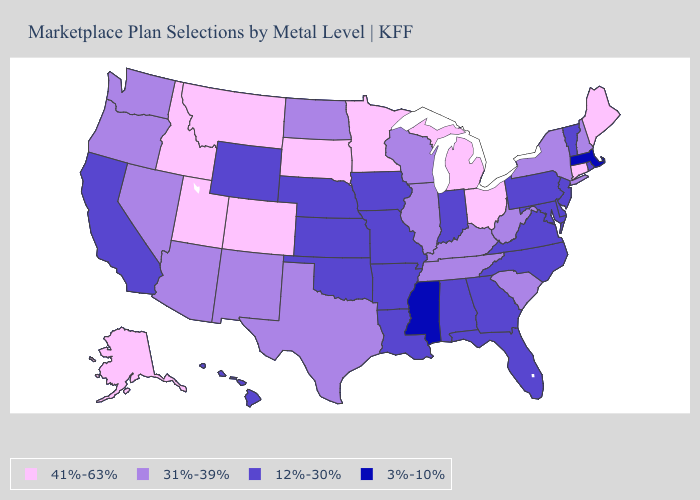Name the states that have a value in the range 41%-63%?
Be succinct. Alaska, Colorado, Connecticut, Idaho, Maine, Michigan, Minnesota, Montana, Ohio, South Dakota, Utah. What is the value of Florida?
Write a very short answer. 12%-30%. Name the states that have a value in the range 3%-10%?
Keep it brief. Massachusetts, Mississippi. What is the value of Wisconsin?
Short answer required. 31%-39%. Does the first symbol in the legend represent the smallest category?
Write a very short answer. No. Is the legend a continuous bar?
Write a very short answer. No. Which states have the lowest value in the MidWest?
Be succinct. Indiana, Iowa, Kansas, Missouri, Nebraska. Name the states that have a value in the range 3%-10%?
Short answer required. Massachusetts, Mississippi. What is the value of Oklahoma?
Keep it brief. 12%-30%. Does Maryland have the lowest value in the USA?
Write a very short answer. No. Does the map have missing data?
Concise answer only. No. Which states hav the highest value in the MidWest?
Give a very brief answer. Michigan, Minnesota, Ohio, South Dakota. What is the value of Colorado?
Short answer required. 41%-63%. Does Nebraska have a higher value than California?
Quick response, please. No. Is the legend a continuous bar?
Give a very brief answer. No. 